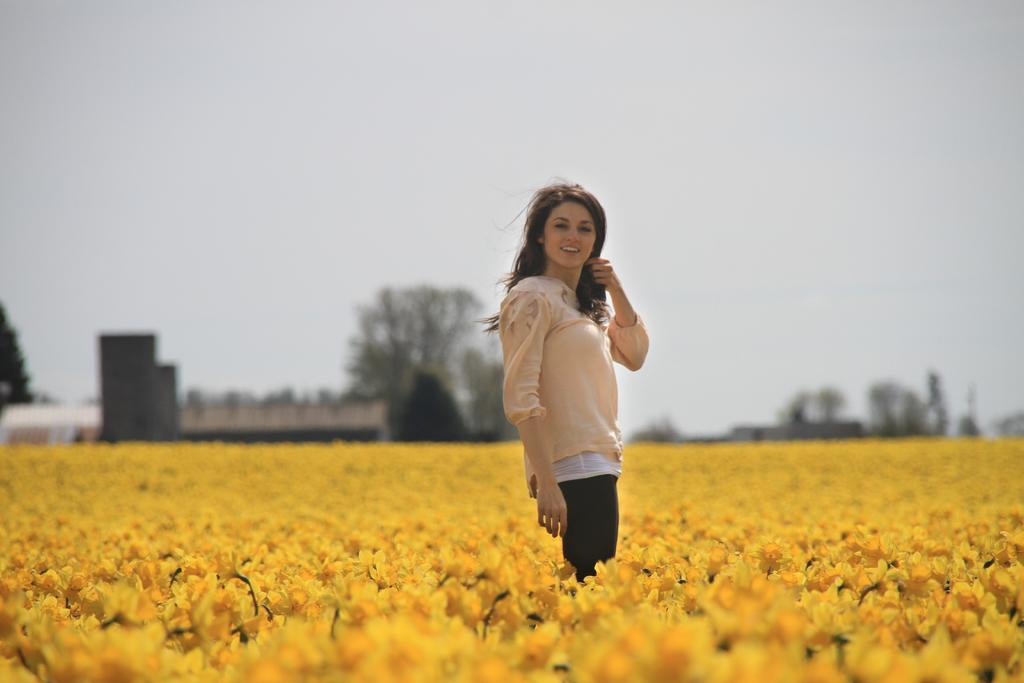What type of landscape is depicted in the image? There is a flower garden in the image. Can you describe the person in the image? A lady is standing in the flower garden. What other structures can be seen in the image? There are houses in the image. What type of vegetation is present in the image? There are many trees in the image. What is visible in the background of the image? The sky is visible in the image. What type of desk is visible in the image? There is no desk present in the image. What color is the gold in the image? There is no gold present in the image. 